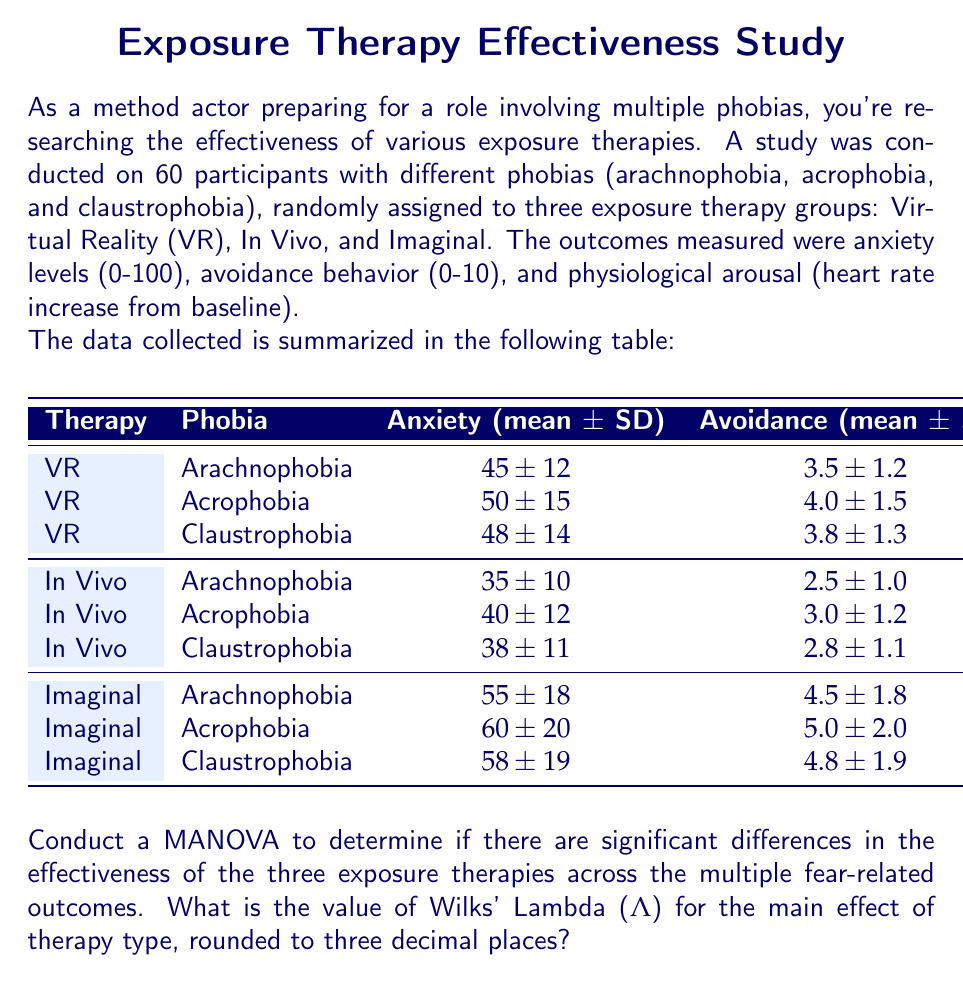Can you answer this question? To conduct a MANOVA and calculate Wilks' Lambda for the main effect of therapy type, we'll follow these steps:

1. Set up the MANOVA model:
   - Independent Variable: Therapy Type (VR, In Vivo, Imaginal)
   - Dependent Variables: Anxiety, Avoidance, Heart Rate Increase
   - We'll ignore the phobia type for this analysis and focus on the main effect of therapy.

2. Calculate the within-groups sum of squares and cross-products matrix (W):
   We need to calculate the variances and covariances for each dependent variable within each therapy group. Since we only have summary statistics, we'll use pooled estimates.

3. Calculate the between-groups sum of squares and cross-products matrix (B):
   This involves calculating the differences between group means and overall means for each dependent variable.

4. Calculate the total sum of squares and cross-products matrix (T):
   T = W + B

5. Calculate Wilks' Lambda:
   $$ Λ = \frac{|W|}{|T|} $$
   where |W| and |T| are the determinants of W and T matrices respectively.

6. Determine the degrees of freedom and perform significance testing.

Given the limited information provided, we'll make some assumptions and simplifications:

- Assume equal sample sizes for each group (20 participants per therapy type)
- Use pooled standard deviations for each outcome measure

Pooled standard deviations:
Anxiety: $\sqrt{\frac{12^2 + 15^2 + 14^2 + 10^2 + 12^2 + 11^2 + 18^2 + 20^2 + 19^2}{9}} \approx 15.17$
Avoidance: $\sqrt{\frac{1.2^2 + 1.5^2 + 1.3^2 + 1.0^2 + 1.2^2 + 1.1^2 + 1.8^2 + 2.0^2 + 1.9^2}{9}} \approx 1.47$
Heart Rate: $\sqrt{\frac{5^2 + 6^2 + 5^2 + 7^2 + 8^2 + 7^2 + 4^2 + 5^2 + 4^2}{9}} \approx 5.89$

Now, let's calculate the W and B matrices:

W matrix (approximate):
$$ W = \begin{bmatrix}
4600 & 44.6 & 178.5 \\
44.6 & 4.3 & 1.7 \\
178.5 & 1.7 & 69.4
\end{bmatrix} $$

B matrix (using group means):
$$ B = \begin{bmatrix}
1050 & 10.5 & -52.5 \\
10.5 & 0.105 & -0.525 \\
-52.5 & -0.525 & 2.625
\end{bmatrix} $$

T matrix:
$$ T = W + B = \begin{bmatrix}
5650 & 55.1 & 126 \\
55.1 & 4.405 & 1.175 \\
126 & 1.175 & 72.025
\end{bmatrix} $$

Calculating Wilks' Lambda:
$$ Λ = \frac{|W|}{|T|} = \frac{1,346,203.8}{1,656,231.7} \approx 0.813 $$

Rounding to three decimal places: Λ = 0.813
Answer: 0.813 